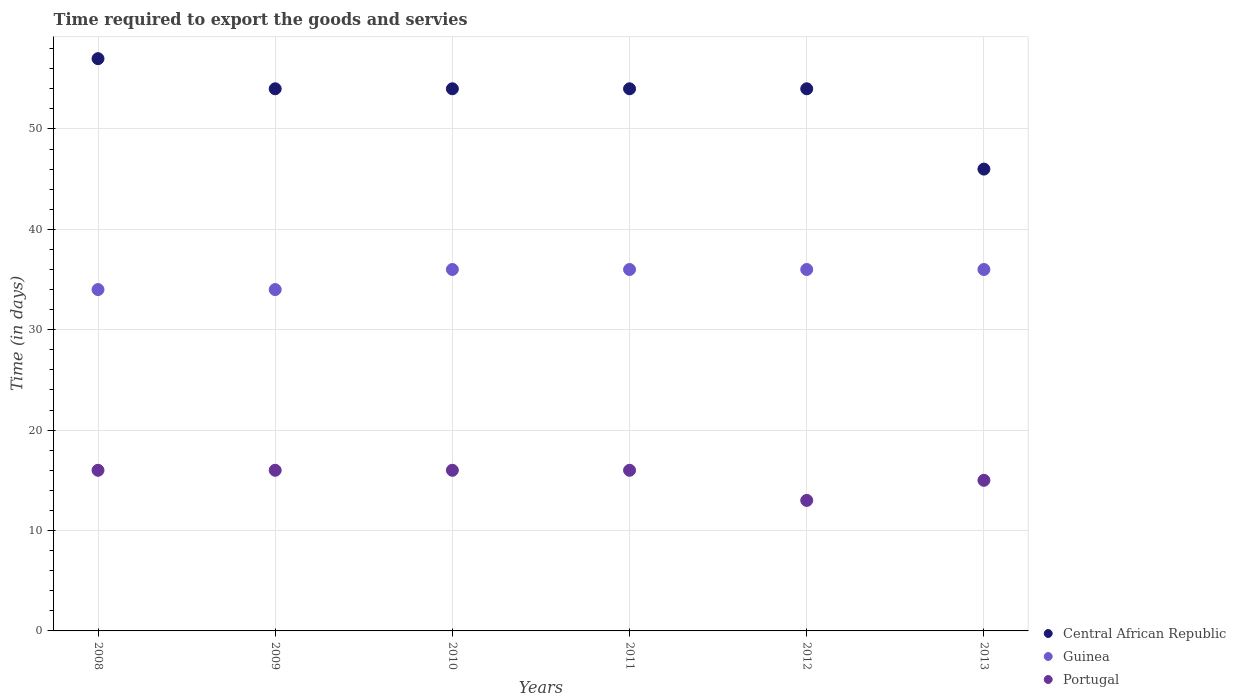How many different coloured dotlines are there?
Make the answer very short. 3. What is the number of days required to export the goods and services in Guinea in 2009?
Your answer should be very brief. 34. Across all years, what is the maximum number of days required to export the goods and services in Central African Republic?
Offer a terse response. 57. Across all years, what is the minimum number of days required to export the goods and services in Guinea?
Your answer should be very brief. 34. In which year was the number of days required to export the goods and services in Guinea maximum?
Provide a succinct answer. 2010. What is the total number of days required to export the goods and services in Portugal in the graph?
Ensure brevity in your answer.  92. What is the difference between the number of days required to export the goods and services in Portugal in 2008 and that in 2013?
Offer a terse response. 1. What is the difference between the number of days required to export the goods and services in Guinea in 2009 and the number of days required to export the goods and services in Portugal in 2012?
Your answer should be compact. 21. What is the average number of days required to export the goods and services in Central African Republic per year?
Your response must be concise. 53.17. In the year 2012, what is the difference between the number of days required to export the goods and services in Portugal and number of days required to export the goods and services in Guinea?
Keep it short and to the point. -23. What is the ratio of the number of days required to export the goods and services in Guinea in 2010 to that in 2013?
Offer a terse response. 1. What is the difference between the highest and the second highest number of days required to export the goods and services in Central African Republic?
Your answer should be compact. 3. What is the difference between the highest and the lowest number of days required to export the goods and services in Guinea?
Make the answer very short. 2. Does the number of days required to export the goods and services in Portugal monotonically increase over the years?
Provide a succinct answer. No. How many dotlines are there?
Offer a very short reply. 3. How many years are there in the graph?
Your answer should be compact. 6. Are the values on the major ticks of Y-axis written in scientific E-notation?
Provide a succinct answer. No. Does the graph contain grids?
Provide a short and direct response. Yes. Where does the legend appear in the graph?
Keep it short and to the point. Bottom right. How are the legend labels stacked?
Your answer should be compact. Vertical. What is the title of the graph?
Keep it short and to the point. Time required to export the goods and servies. What is the label or title of the X-axis?
Provide a short and direct response. Years. What is the label or title of the Y-axis?
Ensure brevity in your answer.  Time (in days). What is the Time (in days) in Guinea in 2008?
Your response must be concise. 34. What is the Time (in days) in Central African Republic in 2009?
Make the answer very short. 54. What is the Time (in days) of Guinea in 2009?
Your response must be concise. 34. What is the Time (in days) in Guinea in 2010?
Provide a short and direct response. 36. What is the Time (in days) in Portugal in 2010?
Make the answer very short. 16. What is the Time (in days) of Central African Republic in 2012?
Offer a terse response. 54. What is the Time (in days) of Portugal in 2012?
Provide a succinct answer. 13. Across all years, what is the maximum Time (in days) in Portugal?
Make the answer very short. 16. What is the total Time (in days) of Central African Republic in the graph?
Ensure brevity in your answer.  319. What is the total Time (in days) of Guinea in the graph?
Your answer should be very brief. 212. What is the total Time (in days) of Portugal in the graph?
Offer a very short reply. 92. What is the difference between the Time (in days) in Guinea in 2008 and that in 2009?
Your response must be concise. 0. What is the difference between the Time (in days) in Portugal in 2008 and that in 2009?
Make the answer very short. 0. What is the difference between the Time (in days) of Central African Republic in 2008 and that in 2010?
Offer a very short reply. 3. What is the difference between the Time (in days) in Portugal in 2008 and that in 2010?
Provide a short and direct response. 0. What is the difference between the Time (in days) of Guinea in 2008 and that in 2011?
Ensure brevity in your answer.  -2. What is the difference between the Time (in days) in Portugal in 2008 and that in 2011?
Offer a terse response. 0. What is the difference between the Time (in days) in Portugal in 2008 and that in 2012?
Provide a short and direct response. 3. What is the difference between the Time (in days) in Guinea in 2009 and that in 2010?
Provide a short and direct response. -2. What is the difference between the Time (in days) of Portugal in 2009 and that in 2010?
Provide a short and direct response. 0. What is the difference between the Time (in days) of Guinea in 2009 and that in 2011?
Give a very brief answer. -2. What is the difference between the Time (in days) of Portugal in 2009 and that in 2011?
Make the answer very short. 0. What is the difference between the Time (in days) in Guinea in 2009 and that in 2013?
Ensure brevity in your answer.  -2. What is the difference between the Time (in days) in Portugal in 2009 and that in 2013?
Offer a terse response. 1. What is the difference between the Time (in days) in Guinea in 2010 and that in 2011?
Keep it short and to the point. 0. What is the difference between the Time (in days) of Central African Republic in 2010 and that in 2012?
Provide a succinct answer. 0. What is the difference between the Time (in days) of Guinea in 2010 and that in 2012?
Your answer should be very brief. 0. What is the difference between the Time (in days) of Portugal in 2010 and that in 2012?
Give a very brief answer. 3. What is the difference between the Time (in days) in Central African Republic in 2010 and that in 2013?
Provide a succinct answer. 8. What is the difference between the Time (in days) in Guinea in 2010 and that in 2013?
Ensure brevity in your answer.  0. What is the difference between the Time (in days) in Central African Republic in 2011 and that in 2012?
Give a very brief answer. 0. What is the difference between the Time (in days) of Central African Republic in 2008 and the Time (in days) of Guinea in 2009?
Provide a short and direct response. 23. What is the difference between the Time (in days) in Central African Republic in 2008 and the Time (in days) in Portugal in 2009?
Make the answer very short. 41. What is the difference between the Time (in days) of Guinea in 2008 and the Time (in days) of Portugal in 2009?
Provide a succinct answer. 18. What is the difference between the Time (in days) in Guinea in 2008 and the Time (in days) in Portugal in 2010?
Your answer should be very brief. 18. What is the difference between the Time (in days) of Central African Republic in 2008 and the Time (in days) of Guinea in 2011?
Your answer should be compact. 21. What is the difference between the Time (in days) of Central African Republic in 2008 and the Time (in days) of Guinea in 2012?
Make the answer very short. 21. What is the difference between the Time (in days) in Guinea in 2008 and the Time (in days) in Portugal in 2012?
Provide a short and direct response. 21. What is the difference between the Time (in days) in Central African Republic in 2008 and the Time (in days) in Guinea in 2013?
Provide a short and direct response. 21. What is the difference between the Time (in days) of Central African Republic in 2008 and the Time (in days) of Portugal in 2013?
Your answer should be very brief. 42. What is the difference between the Time (in days) of Central African Republic in 2009 and the Time (in days) of Portugal in 2010?
Offer a very short reply. 38. What is the difference between the Time (in days) in Central African Republic in 2009 and the Time (in days) in Portugal in 2011?
Ensure brevity in your answer.  38. What is the difference between the Time (in days) of Guinea in 2009 and the Time (in days) of Portugal in 2011?
Provide a succinct answer. 18. What is the difference between the Time (in days) in Central African Republic in 2009 and the Time (in days) in Guinea in 2013?
Keep it short and to the point. 18. What is the difference between the Time (in days) in Guinea in 2009 and the Time (in days) in Portugal in 2013?
Provide a succinct answer. 19. What is the difference between the Time (in days) in Central African Republic in 2010 and the Time (in days) in Guinea in 2011?
Ensure brevity in your answer.  18. What is the difference between the Time (in days) in Guinea in 2010 and the Time (in days) in Portugal in 2011?
Give a very brief answer. 20. What is the difference between the Time (in days) in Central African Republic in 2010 and the Time (in days) in Portugal in 2012?
Your answer should be compact. 41. What is the difference between the Time (in days) of Guinea in 2010 and the Time (in days) of Portugal in 2012?
Offer a terse response. 23. What is the difference between the Time (in days) of Central African Republic in 2010 and the Time (in days) of Guinea in 2013?
Your answer should be very brief. 18. What is the difference between the Time (in days) in Central African Republic in 2011 and the Time (in days) in Guinea in 2012?
Make the answer very short. 18. What is the difference between the Time (in days) in Central African Republic in 2011 and the Time (in days) in Portugal in 2012?
Keep it short and to the point. 41. What is the difference between the Time (in days) in Central African Republic in 2011 and the Time (in days) in Guinea in 2013?
Give a very brief answer. 18. What is the difference between the Time (in days) in Central African Republic in 2011 and the Time (in days) in Portugal in 2013?
Provide a succinct answer. 39. What is the average Time (in days) in Central African Republic per year?
Provide a short and direct response. 53.17. What is the average Time (in days) of Guinea per year?
Ensure brevity in your answer.  35.33. What is the average Time (in days) of Portugal per year?
Offer a very short reply. 15.33. In the year 2008, what is the difference between the Time (in days) in Central African Republic and Time (in days) in Guinea?
Provide a short and direct response. 23. In the year 2008, what is the difference between the Time (in days) of Guinea and Time (in days) of Portugal?
Your answer should be very brief. 18. In the year 2009, what is the difference between the Time (in days) of Central African Republic and Time (in days) of Portugal?
Your answer should be compact. 38. In the year 2010, what is the difference between the Time (in days) of Guinea and Time (in days) of Portugal?
Give a very brief answer. 20. In the year 2011, what is the difference between the Time (in days) in Central African Republic and Time (in days) in Portugal?
Give a very brief answer. 38. In the year 2012, what is the difference between the Time (in days) in Central African Republic and Time (in days) in Portugal?
Offer a very short reply. 41. In the year 2012, what is the difference between the Time (in days) in Guinea and Time (in days) in Portugal?
Make the answer very short. 23. In the year 2013, what is the difference between the Time (in days) in Guinea and Time (in days) in Portugal?
Give a very brief answer. 21. What is the ratio of the Time (in days) of Central African Republic in 2008 to that in 2009?
Offer a terse response. 1.06. What is the ratio of the Time (in days) of Guinea in 2008 to that in 2009?
Offer a very short reply. 1. What is the ratio of the Time (in days) in Central African Republic in 2008 to that in 2010?
Offer a very short reply. 1.06. What is the ratio of the Time (in days) in Guinea in 2008 to that in 2010?
Give a very brief answer. 0.94. What is the ratio of the Time (in days) in Central African Republic in 2008 to that in 2011?
Your response must be concise. 1.06. What is the ratio of the Time (in days) in Guinea in 2008 to that in 2011?
Keep it short and to the point. 0.94. What is the ratio of the Time (in days) in Central African Republic in 2008 to that in 2012?
Your response must be concise. 1.06. What is the ratio of the Time (in days) of Portugal in 2008 to that in 2012?
Offer a very short reply. 1.23. What is the ratio of the Time (in days) in Central African Republic in 2008 to that in 2013?
Provide a short and direct response. 1.24. What is the ratio of the Time (in days) in Portugal in 2008 to that in 2013?
Make the answer very short. 1.07. What is the ratio of the Time (in days) in Portugal in 2009 to that in 2010?
Ensure brevity in your answer.  1. What is the ratio of the Time (in days) in Portugal in 2009 to that in 2011?
Keep it short and to the point. 1. What is the ratio of the Time (in days) in Central African Republic in 2009 to that in 2012?
Provide a short and direct response. 1. What is the ratio of the Time (in days) in Portugal in 2009 to that in 2012?
Your response must be concise. 1.23. What is the ratio of the Time (in days) of Central African Republic in 2009 to that in 2013?
Your answer should be compact. 1.17. What is the ratio of the Time (in days) in Guinea in 2009 to that in 2013?
Your response must be concise. 0.94. What is the ratio of the Time (in days) of Portugal in 2009 to that in 2013?
Provide a short and direct response. 1.07. What is the ratio of the Time (in days) in Central African Republic in 2010 to that in 2011?
Provide a succinct answer. 1. What is the ratio of the Time (in days) of Portugal in 2010 to that in 2011?
Your answer should be very brief. 1. What is the ratio of the Time (in days) in Central African Republic in 2010 to that in 2012?
Provide a succinct answer. 1. What is the ratio of the Time (in days) of Portugal in 2010 to that in 2012?
Ensure brevity in your answer.  1.23. What is the ratio of the Time (in days) of Central African Republic in 2010 to that in 2013?
Give a very brief answer. 1.17. What is the ratio of the Time (in days) in Guinea in 2010 to that in 2013?
Make the answer very short. 1. What is the ratio of the Time (in days) in Portugal in 2010 to that in 2013?
Your response must be concise. 1.07. What is the ratio of the Time (in days) in Portugal in 2011 to that in 2012?
Provide a succinct answer. 1.23. What is the ratio of the Time (in days) of Central African Republic in 2011 to that in 2013?
Ensure brevity in your answer.  1.17. What is the ratio of the Time (in days) in Portugal in 2011 to that in 2013?
Provide a succinct answer. 1.07. What is the ratio of the Time (in days) in Central African Republic in 2012 to that in 2013?
Give a very brief answer. 1.17. What is the ratio of the Time (in days) in Portugal in 2012 to that in 2013?
Offer a terse response. 0.87. What is the difference between the highest and the second highest Time (in days) of Central African Republic?
Your answer should be compact. 3. What is the difference between the highest and the second highest Time (in days) in Portugal?
Offer a terse response. 0. 